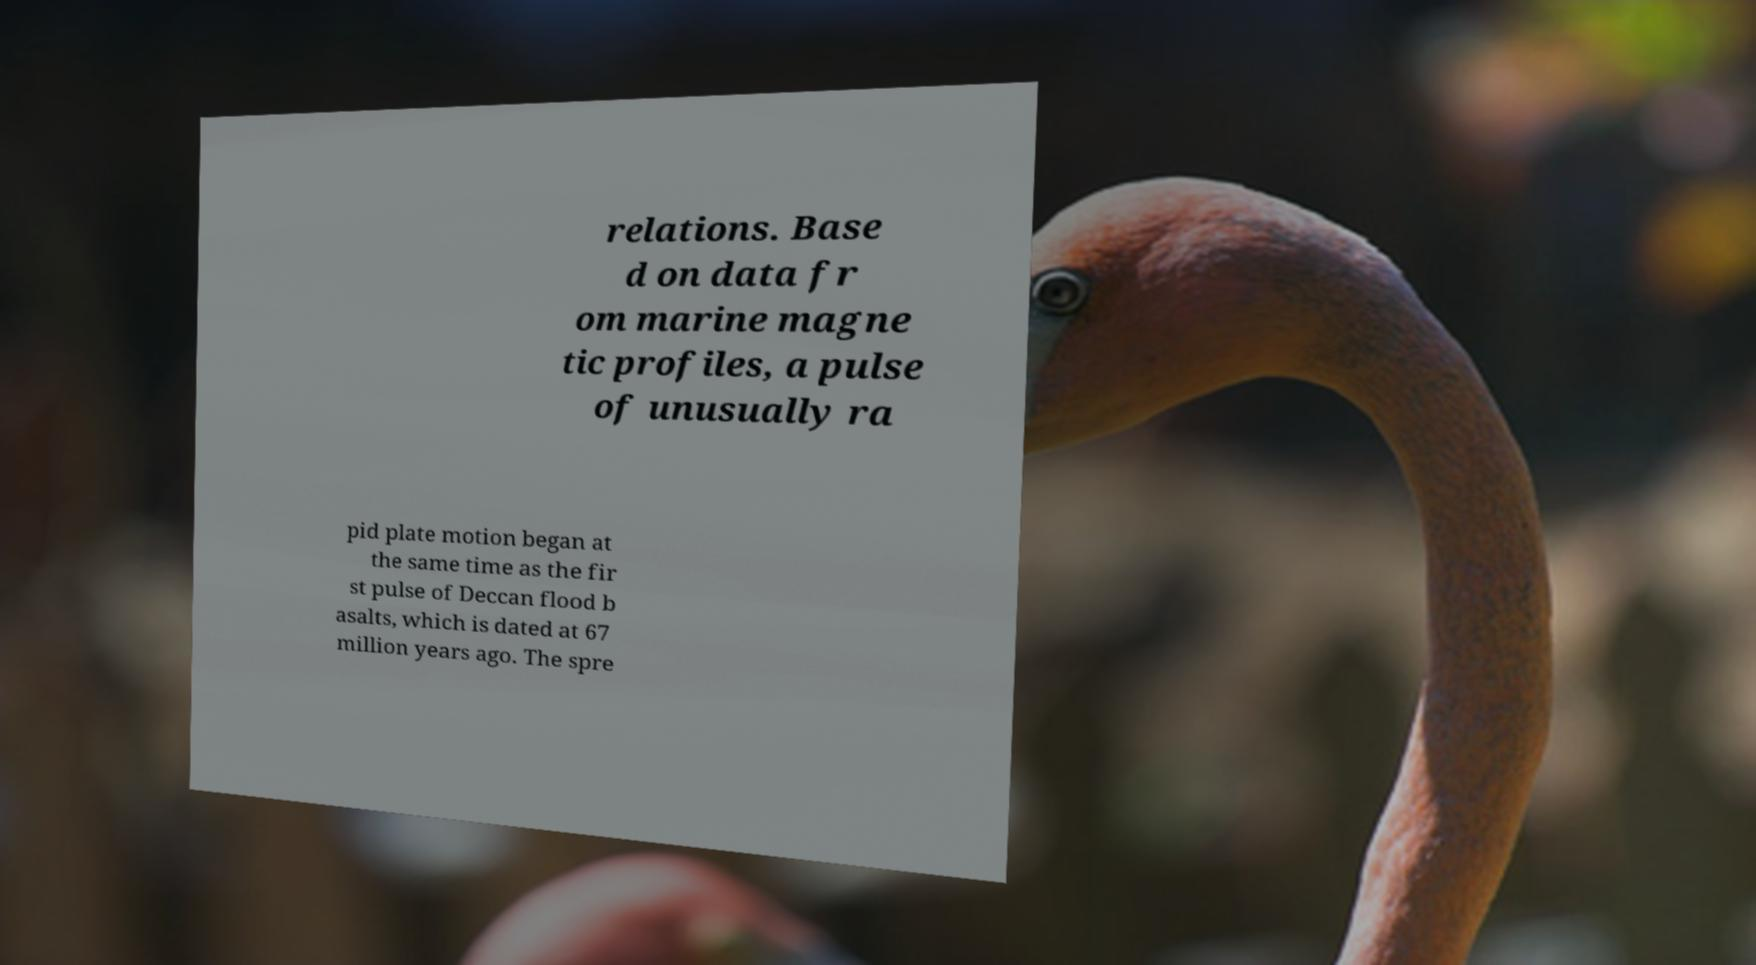There's text embedded in this image that I need extracted. Can you transcribe it verbatim? relations. Base d on data fr om marine magne tic profiles, a pulse of unusually ra pid plate motion began at the same time as the fir st pulse of Deccan flood b asalts, which is dated at 67 million years ago. The spre 